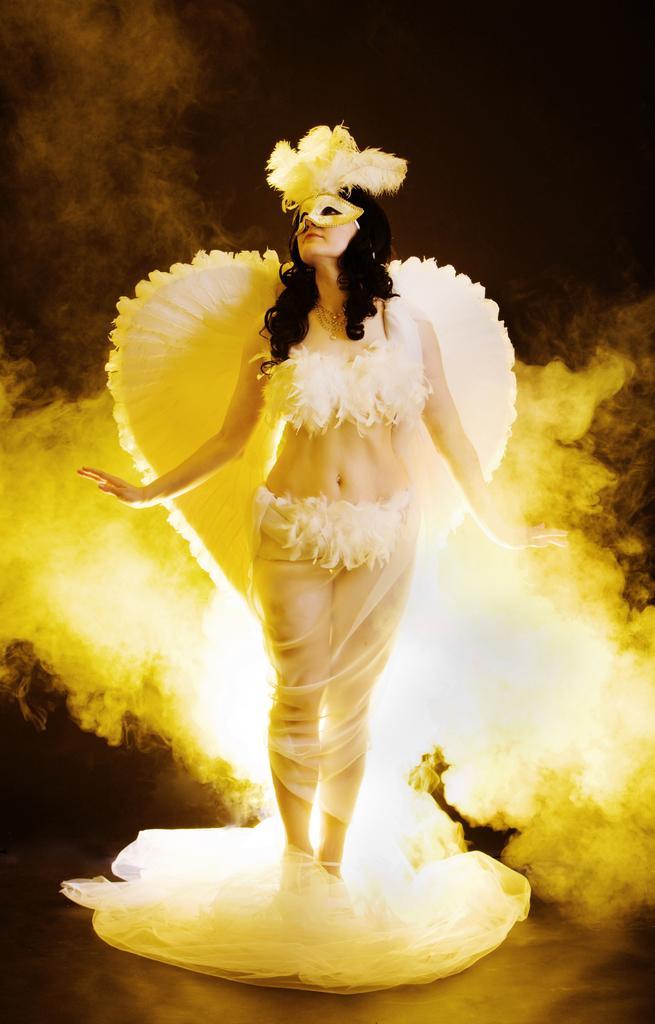Please provide a concise description of this image. In this image we can see a lady dressed up like an angel. 